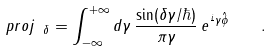<formula> <loc_0><loc_0><loc_500><loc_500>\ p r o j _ { \ \delta } = \int _ { - \infty } ^ { + \infty } d \gamma \, \frac { \sin ( \delta \gamma / \hbar { ) } } { \pi \gamma } \, e ^ { \frac { i } { } \gamma \hat { \phi } } \quad .</formula> 